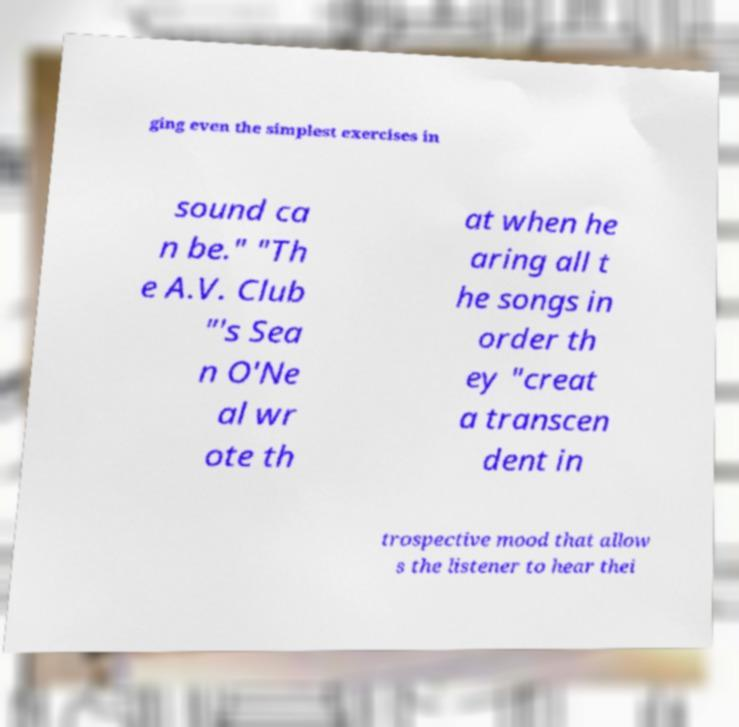Please read and relay the text visible in this image. What does it say? ging even the simplest exercises in sound ca n be." "Th e A.V. Club "'s Sea n O'Ne al wr ote th at when he aring all t he songs in order th ey "creat a transcen dent in trospective mood that allow s the listener to hear thei 